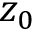Convert formula to latex. <formula><loc_0><loc_0><loc_500><loc_500>z _ { 0 }</formula> 